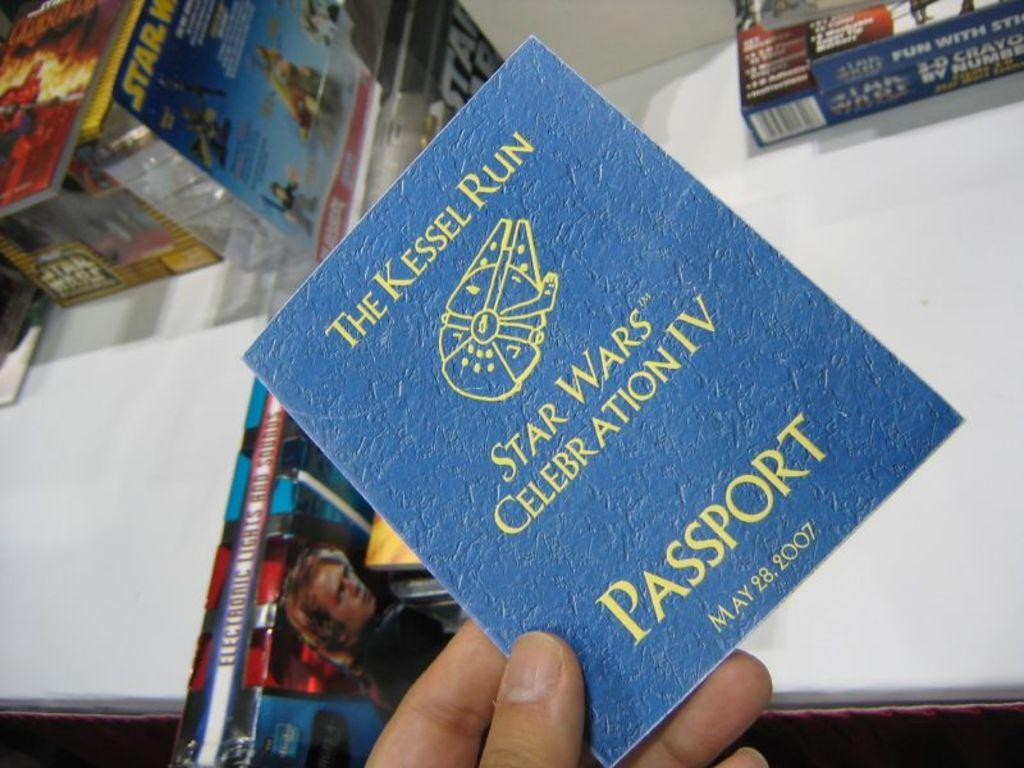<image>
Give a short and clear explanation of the subsequent image. a blue passport that says 'the kessel run star wars celebration IV' on it 